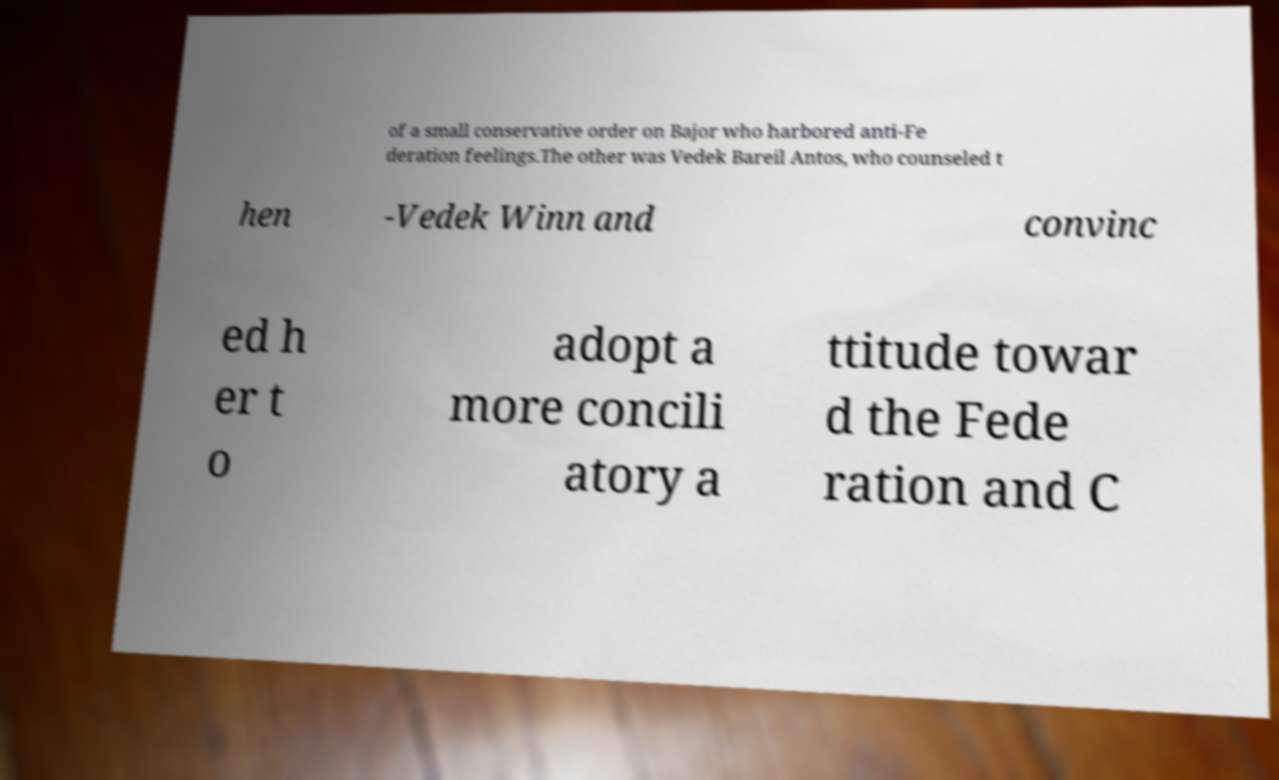Can you accurately transcribe the text from the provided image for me? of a small conservative order on Bajor who harbored anti-Fe deration feelings.The other was Vedek Bareil Antos, who counseled t hen -Vedek Winn and convinc ed h er t o adopt a more concili atory a ttitude towar d the Fede ration and C 